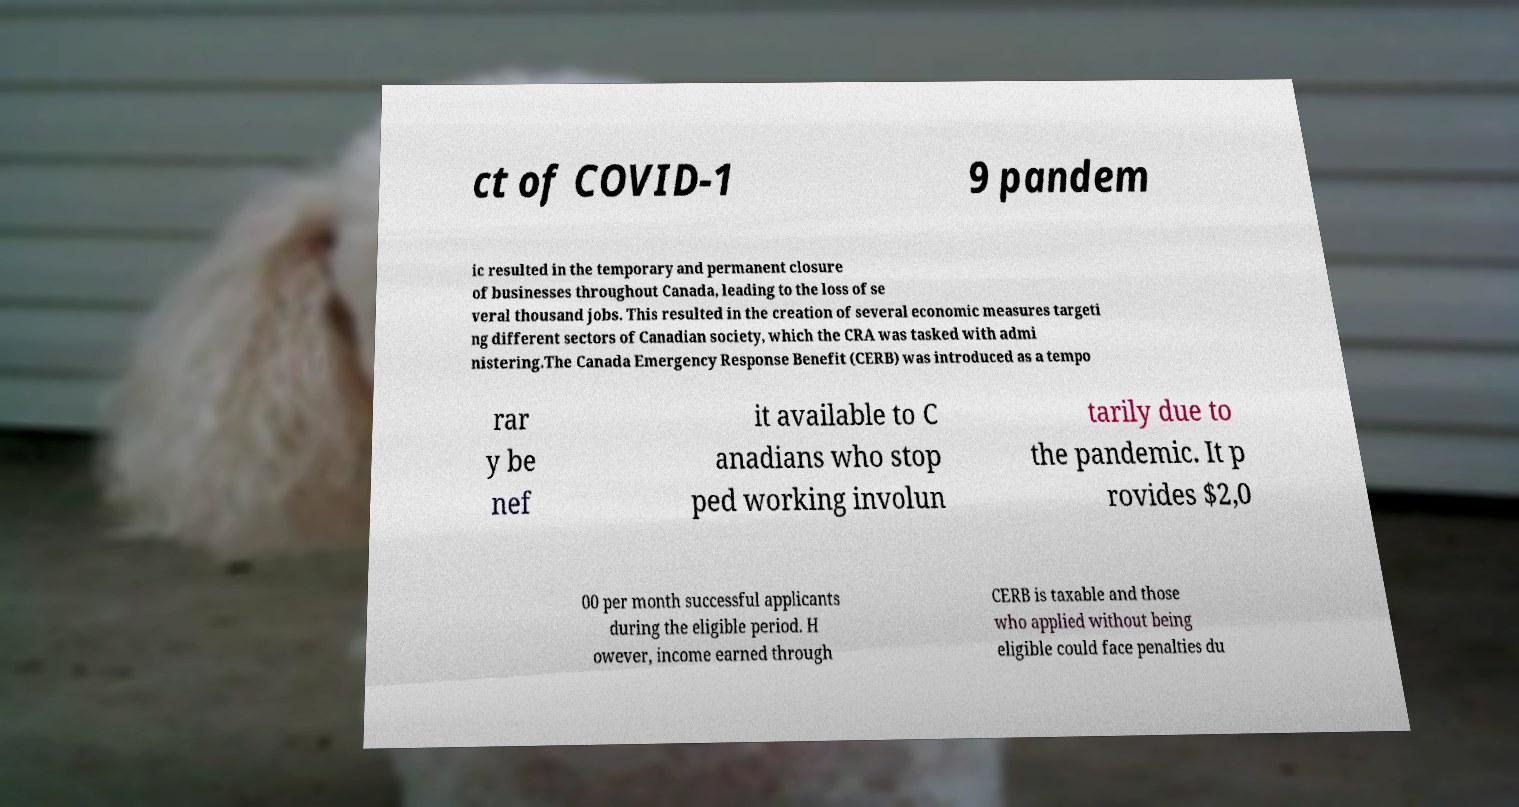Please read and relay the text visible in this image. What does it say? ct of COVID-1 9 pandem ic resulted in the temporary and permanent closure of businesses throughout Canada, leading to the loss of se veral thousand jobs. This resulted in the creation of several economic measures targeti ng different sectors of Canadian society, which the CRA was tasked with admi nistering.The Canada Emergency Response Benefit (CERB) was introduced as a tempo rar y be nef it available to C anadians who stop ped working involun tarily due to the pandemic. It p rovides $2,0 00 per month successful applicants during the eligible period. H owever, income earned through CERB is taxable and those who applied without being eligible could face penalties du 